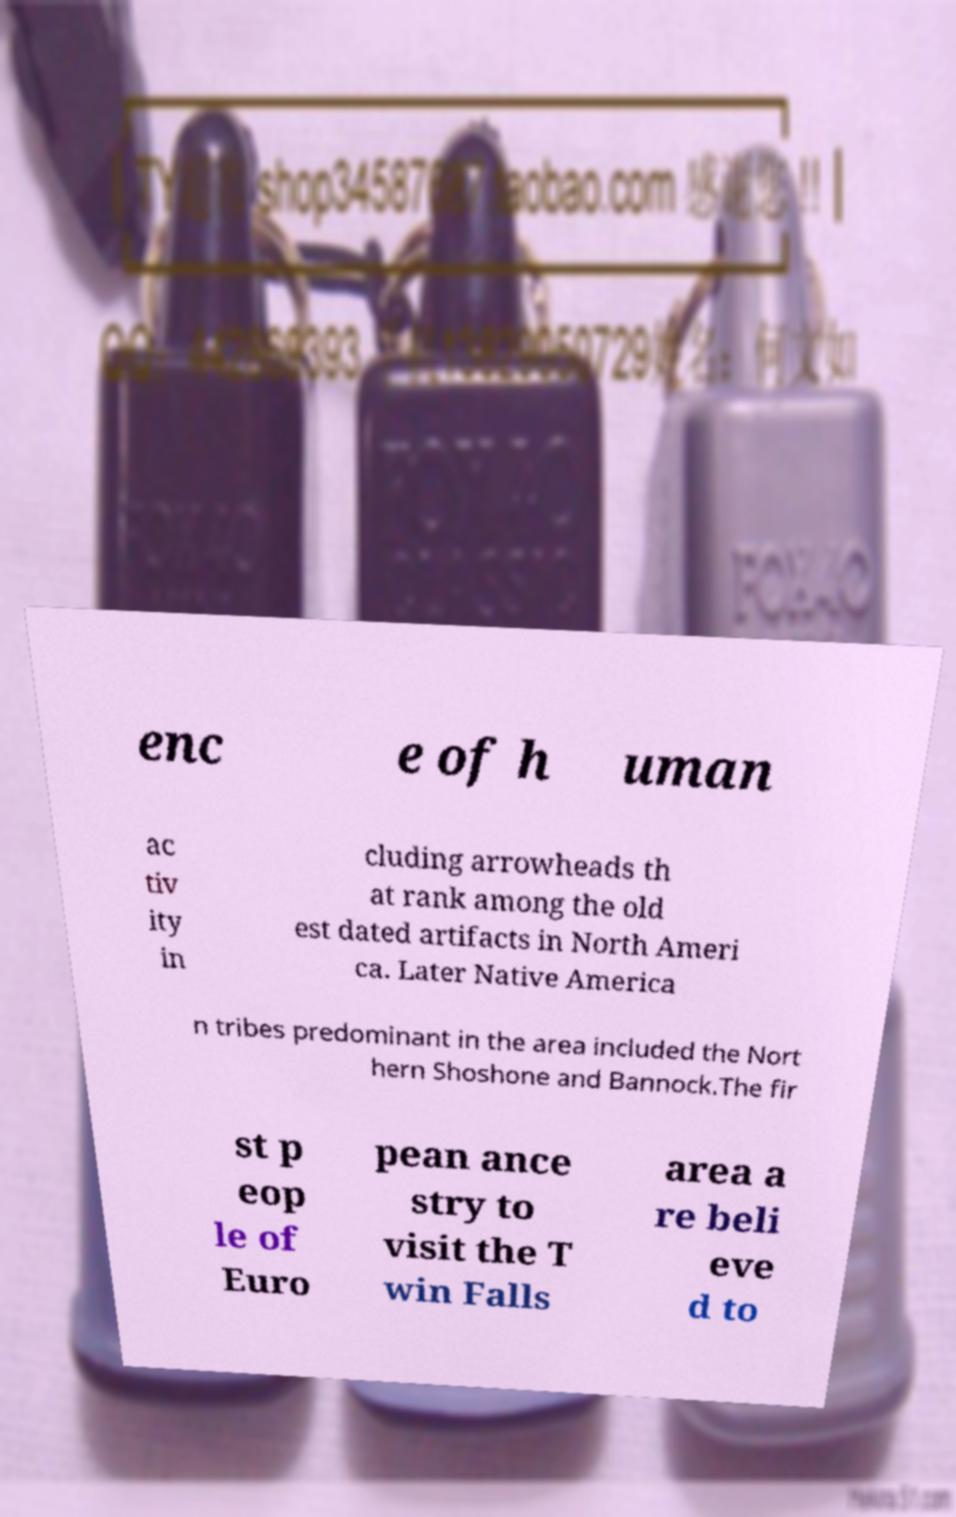Can you accurately transcribe the text from the provided image for me? enc e of h uman ac tiv ity in cluding arrowheads th at rank among the old est dated artifacts in North Ameri ca. Later Native America n tribes predominant in the area included the Nort hern Shoshone and Bannock.The fir st p eop le of Euro pean ance stry to visit the T win Falls area a re beli eve d to 